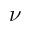Convert formula to latex. <formula><loc_0><loc_0><loc_500><loc_500>\nu</formula> 